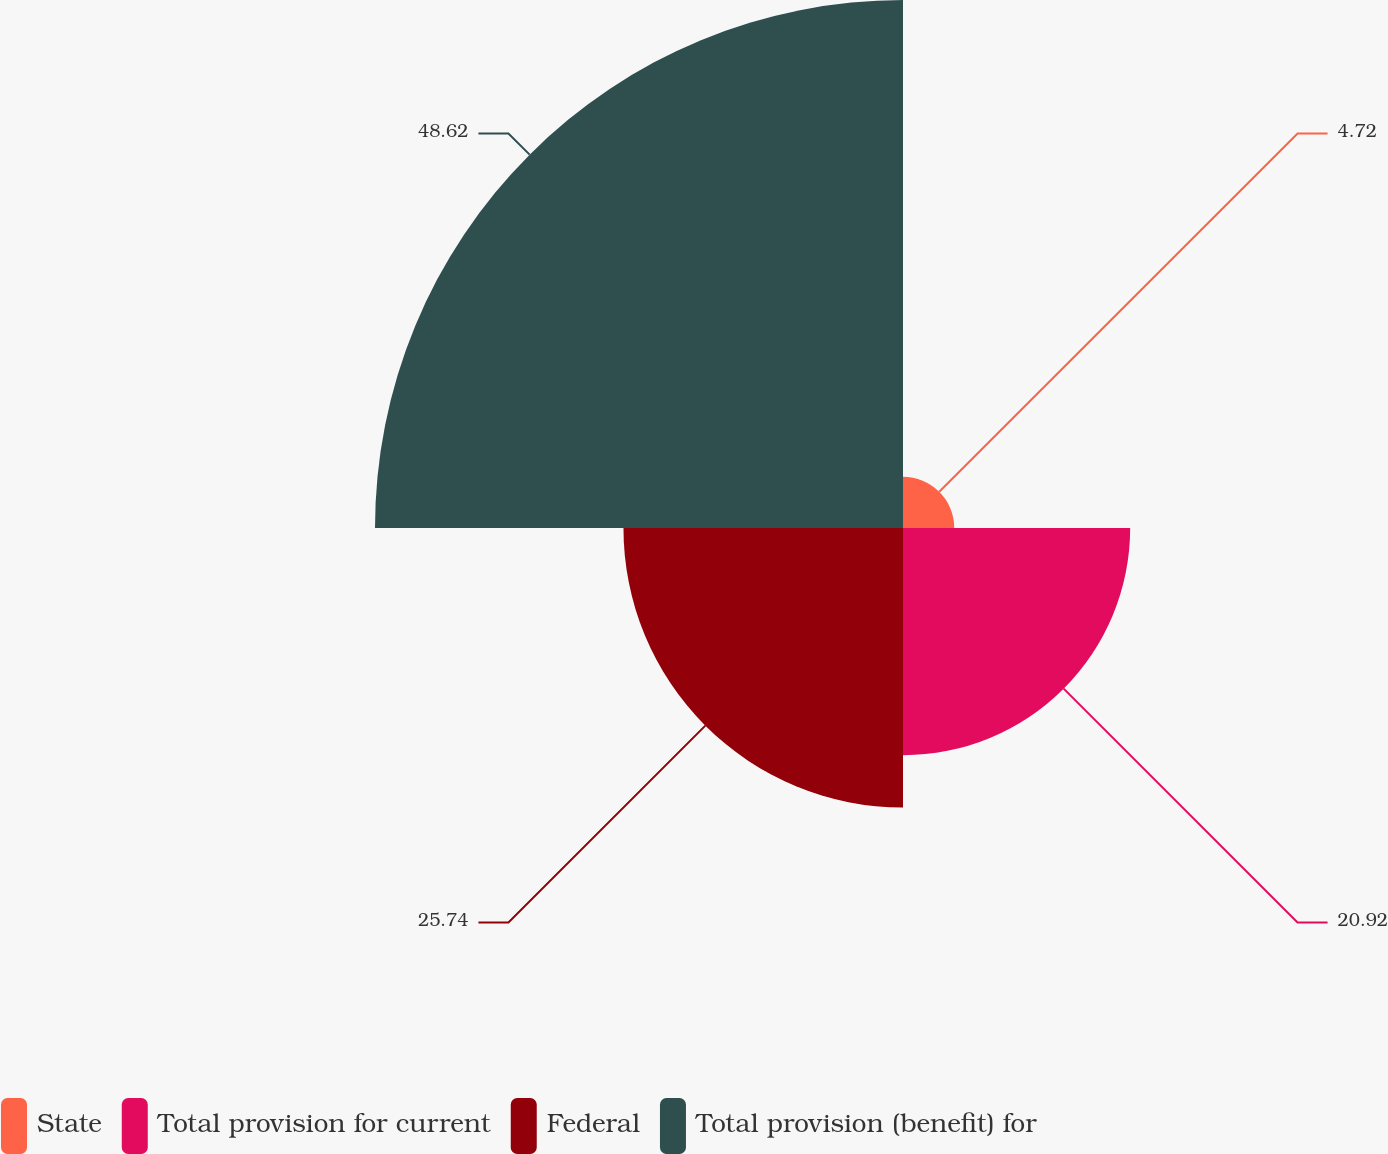Convert chart. <chart><loc_0><loc_0><loc_500><loc_500><pie_chart><fcel>State<fcel>Total provision for current<fcel>Federal<fcel>Total provision (benefit) for<nl><fcel>4.72%<fcel>20.92%<fcel>25.74%<fcel>48.62%<nl></chart> 